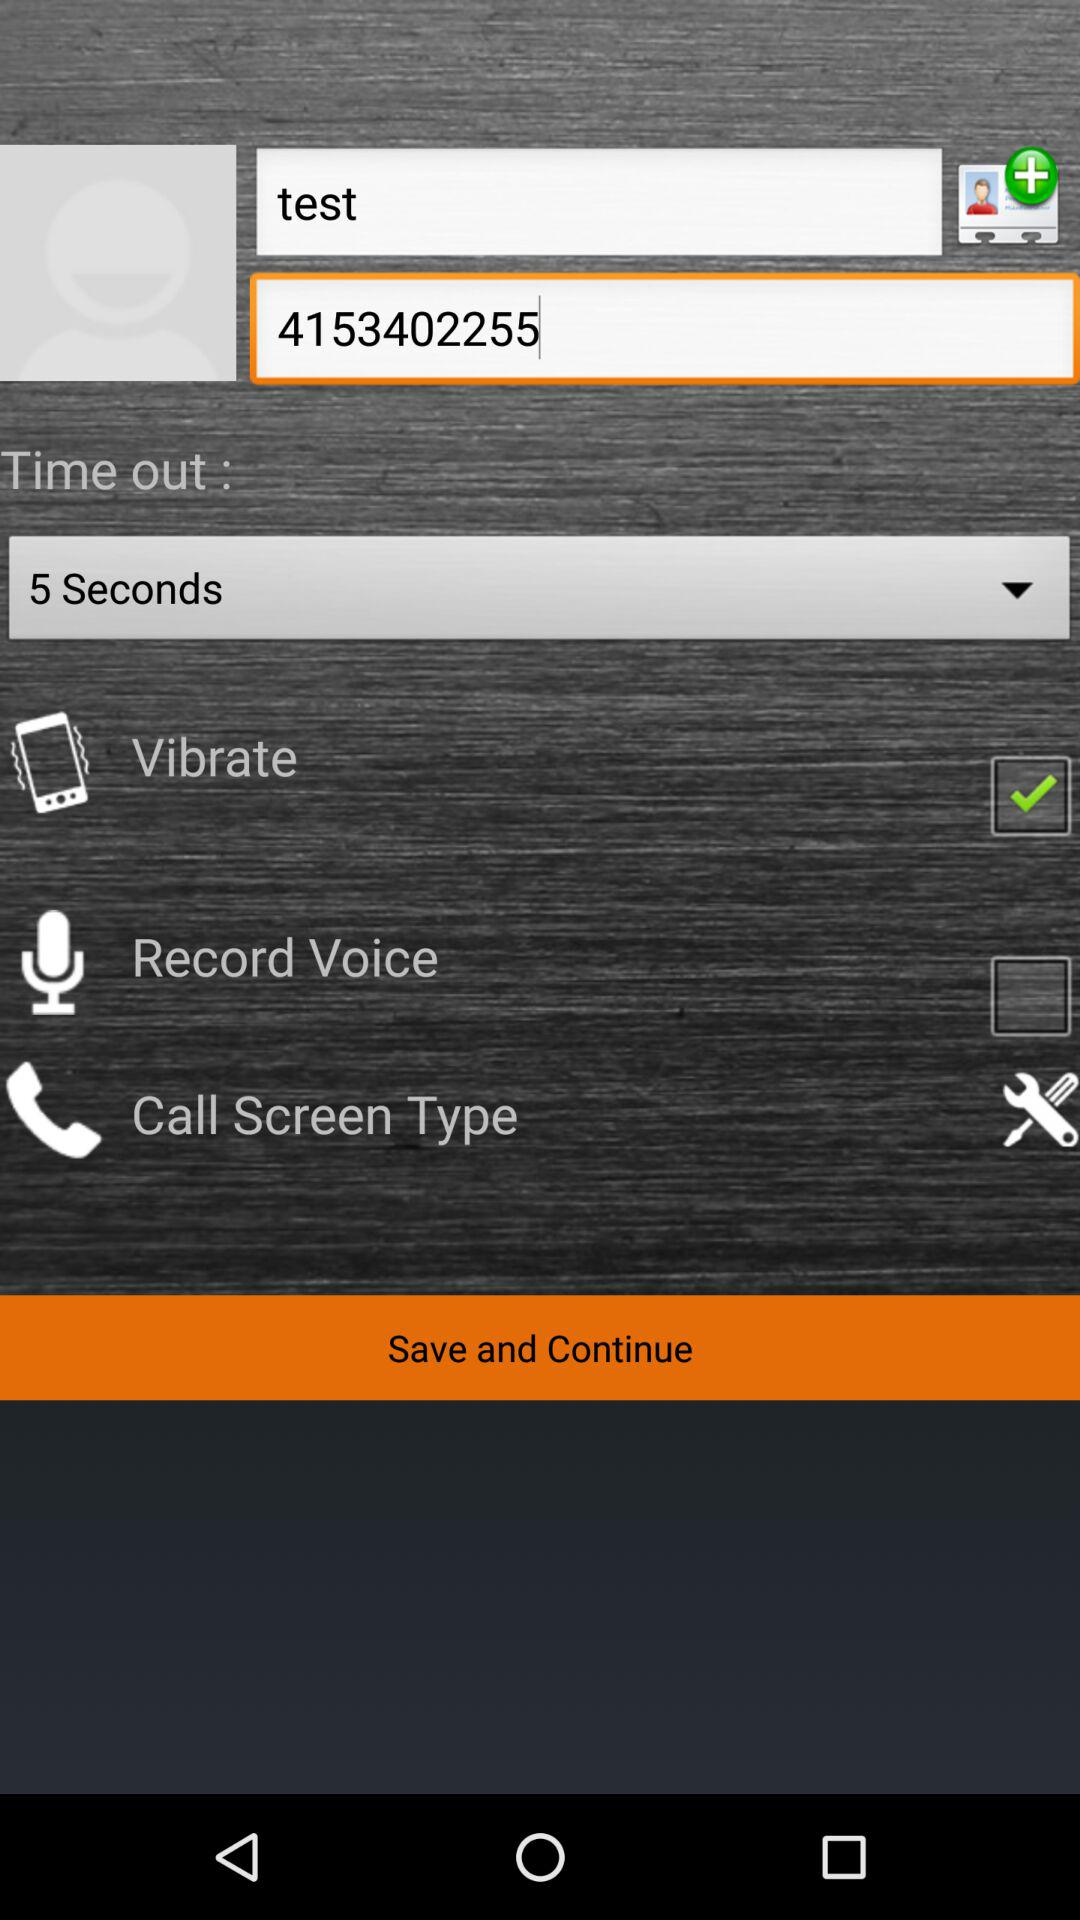What is the status of "Record Voice"? The status is "off". 